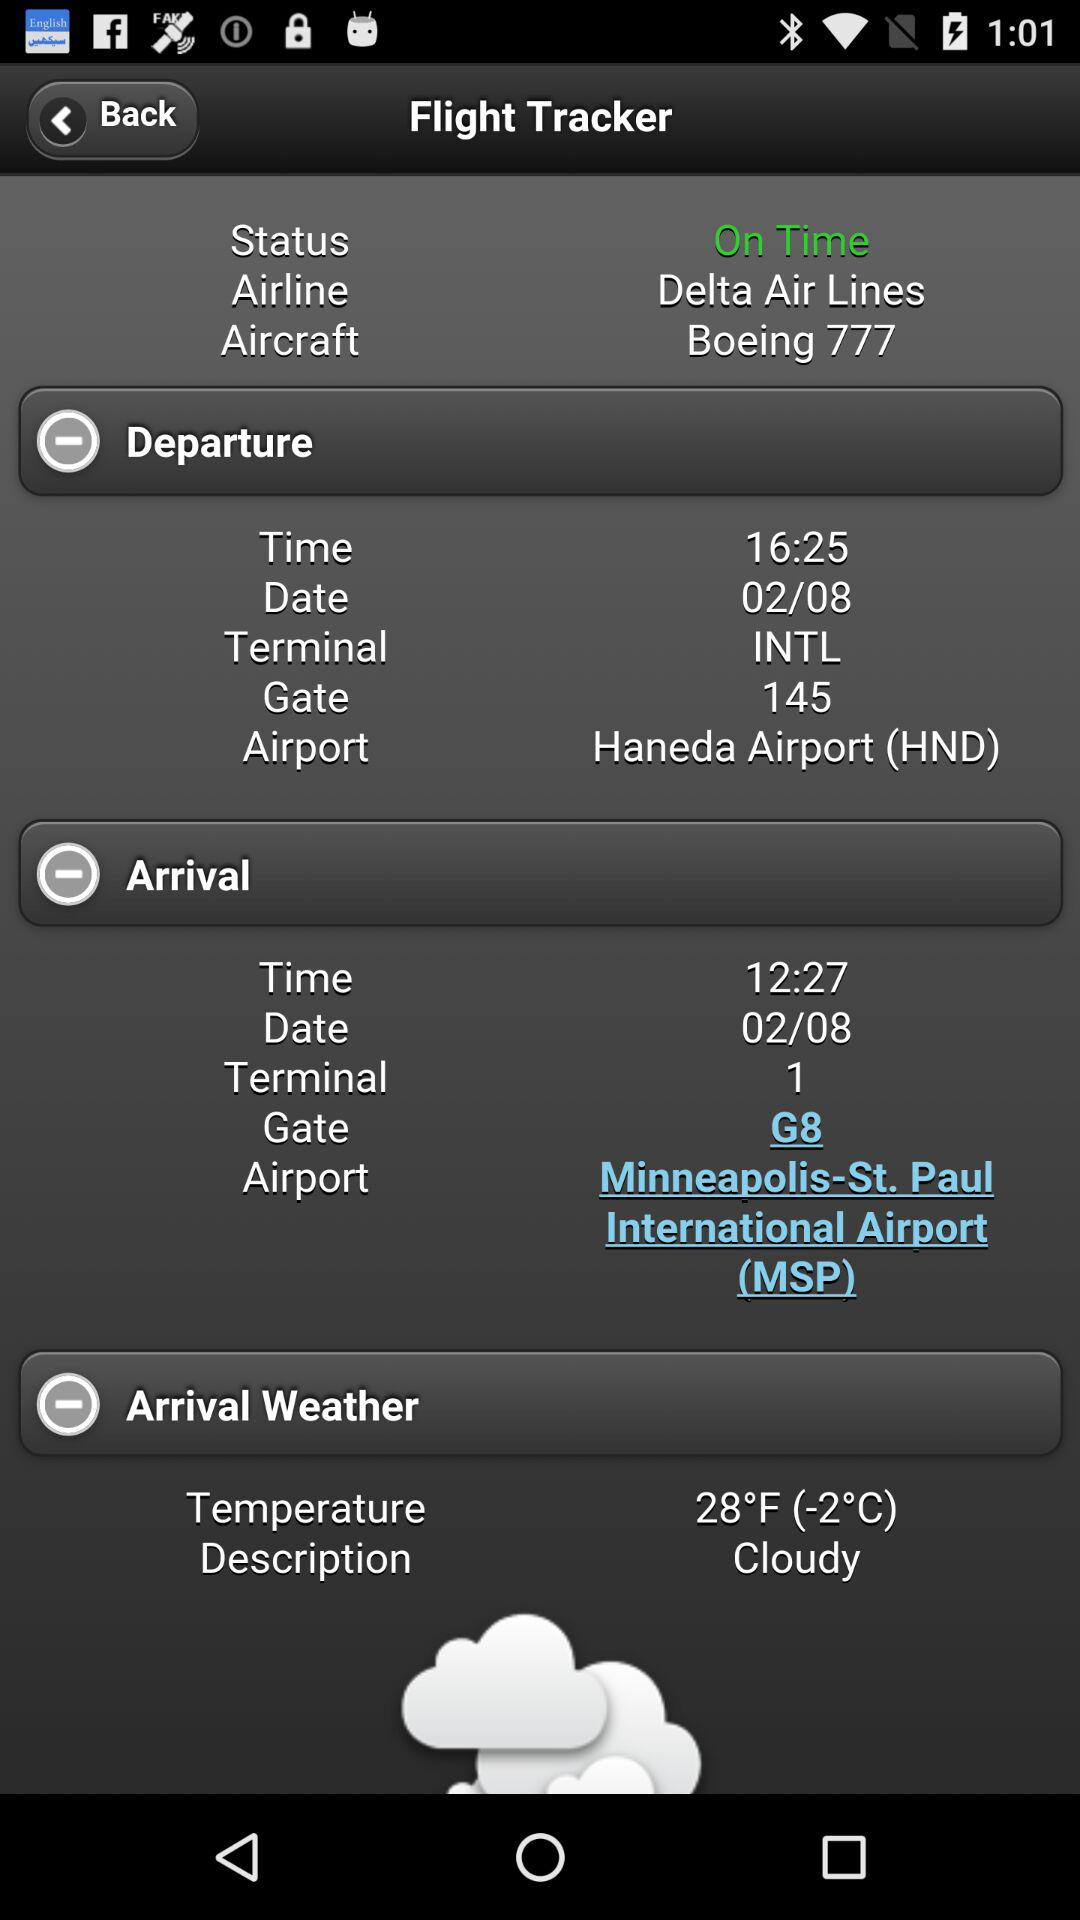What is the status of the flight? The status is "On Time". 